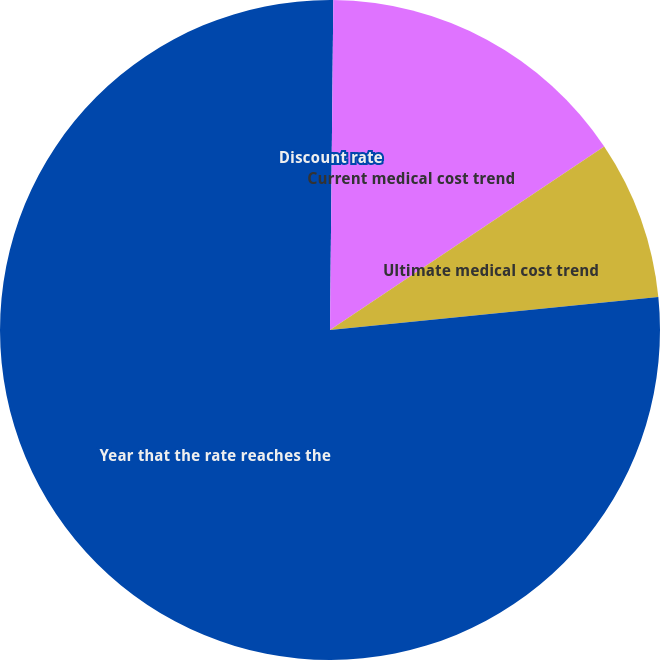Convert chart to OTSL. <chart><loc_0><loc_0><loc_500><loc_500><pie_chart><fcel>Discount rate<fcel>Current medical cost trend<fcel>Ultimate medical cost trend<fcel>Year that the rate reaches the<nl><fcel>0.16%<fcel>15.45%<fcel>7.8%<fcel>76.59%<nl></chart> 